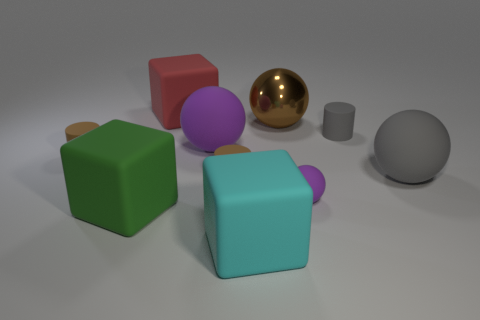What is the material of the gray thing that is the same size as the red block?
Make the answer very short. Rubber. There is a cylinder that is to the left of the red matte block; is it the same size as the matte block that is in front of the green matte object?
Provide a short and direct response. No. What number of things are either large matte cubes or tiny cylinders left of the gray rubber cylinder?
Your answer should be compact. 5. Are there any large gray objects that have the same shape as the brown metallic thing?
Keep it short and to the point. Yes. There is a matte object on the right side of the small gray thing that is behind the large green matte object; what size is it?
Ensure brevity in your answer.  Large. Is the small sphere the same color as the big metallic ball?
Your answer should be very brief. No. How many metallic things are either red objects or small gray objects?
Your answer should be very brief. 0. What number of large blue objects are there?
Ensure brevity in your answer.  0. Is the cylinder that is to the left of the big purple sphere made of the same material as the gray thing in front of the tiny gray cylinder?
Provide a succinct answer. Yes. The small matte thing that is the same shape as the brown metallic thing is what color?
Give a very brief answer. Purple. 